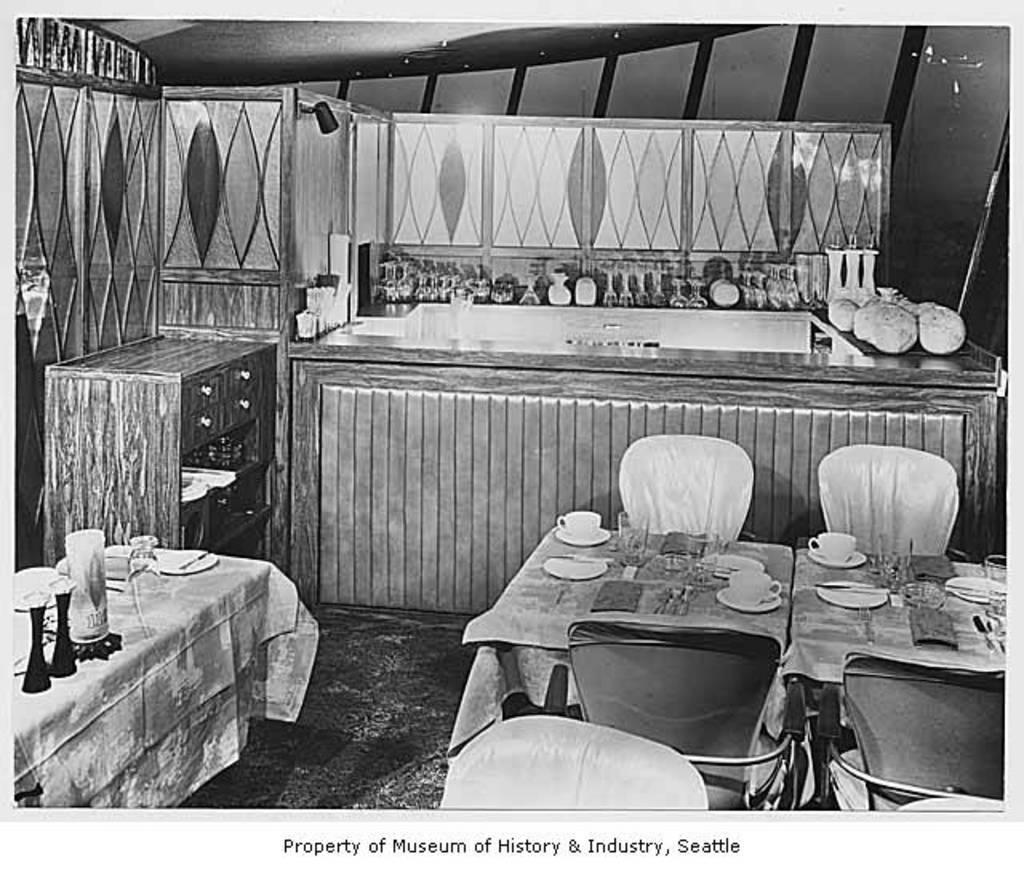Can you describe this image briefly? On the left side, there are plates and bottles on the table, which is covered with a cloth. On the right side, there are chairs arranged on the table, which is covered with a cloth, on which there are cups on the saucers, there are glasses and other objects. In the background, there are bottles and other objects on the table, near the wall. 